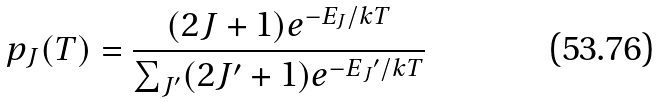<formula> <loc_0><loc_0><loc_500><loc_500>p _ { J } ( T ) = \frac { ( 2 J + 1 ) e ^ { - E _ { J } / k T } } { \sum _ { J { ^ { \prime } } } ( 2 J { ^ { \prime } } + 1 ) e ^ { - E { _ { J } { ^ { \prime } } } / k T } }</formula> 